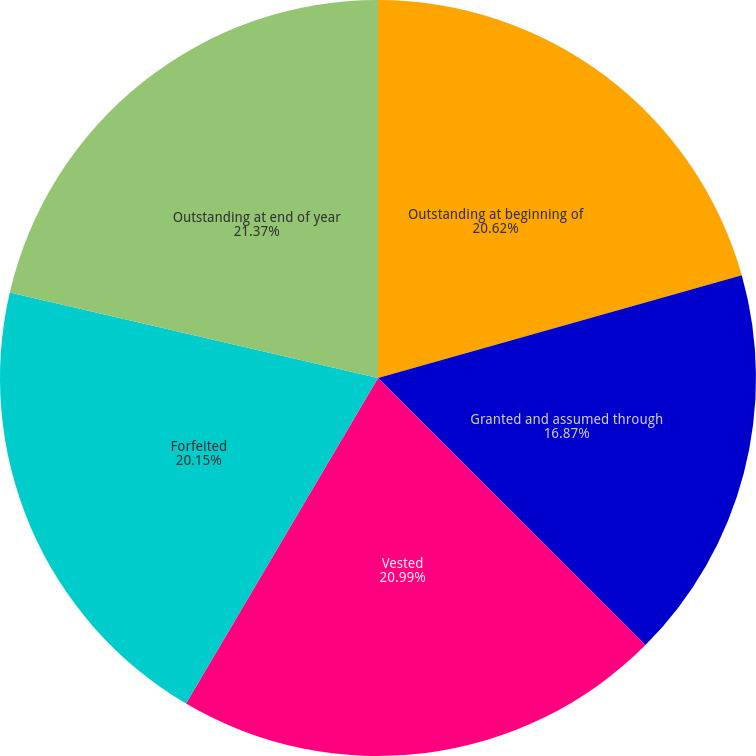<chart> <loc_0><loc_0><loc_500><loc_500><pie_chart><fcel>Outstanding at beginning of<fcel>Granted and assumed through<fcel>Vested<fcel>Forfeited<fcel>Outstanding at end of year<nl><fcel>20.62%<fcel>16.87%<fcel>20.99%<fcel>20.15%<fcel>21.37%<nl></chart> 